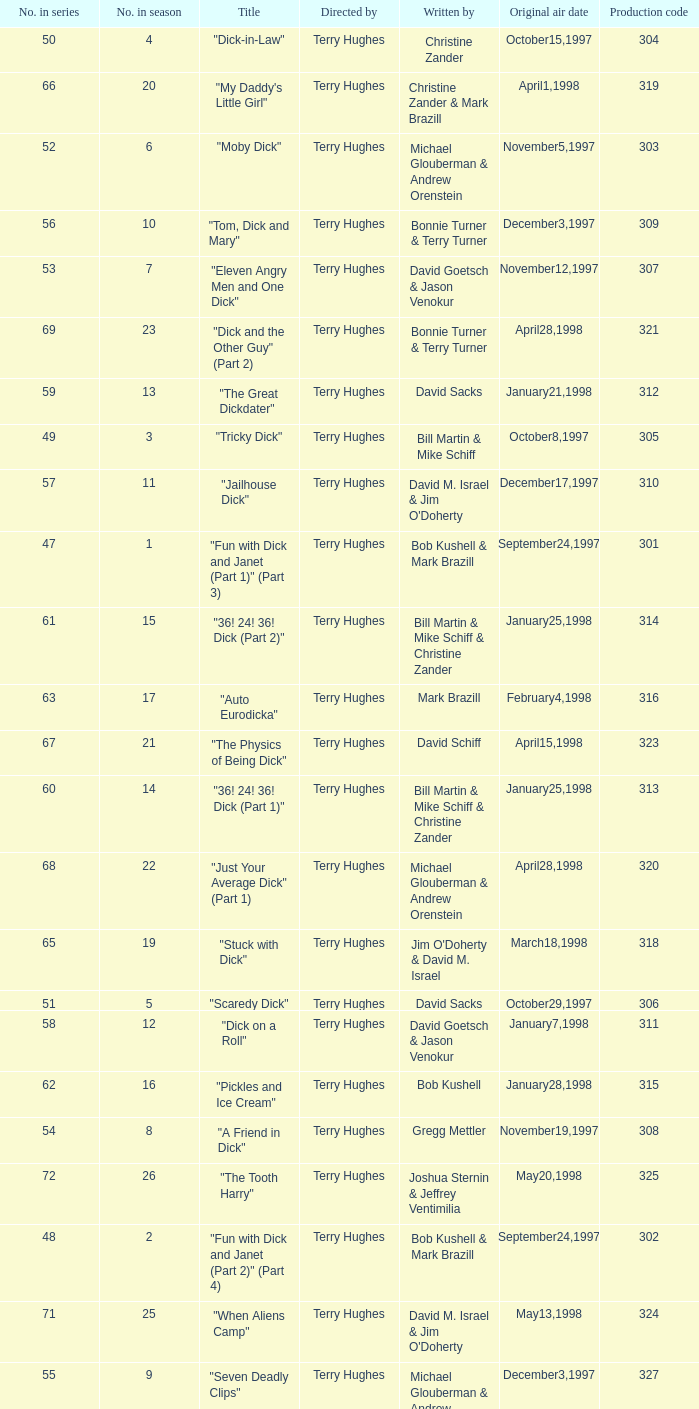What is the original air date of the episode with production code is 319? April1,1998. 